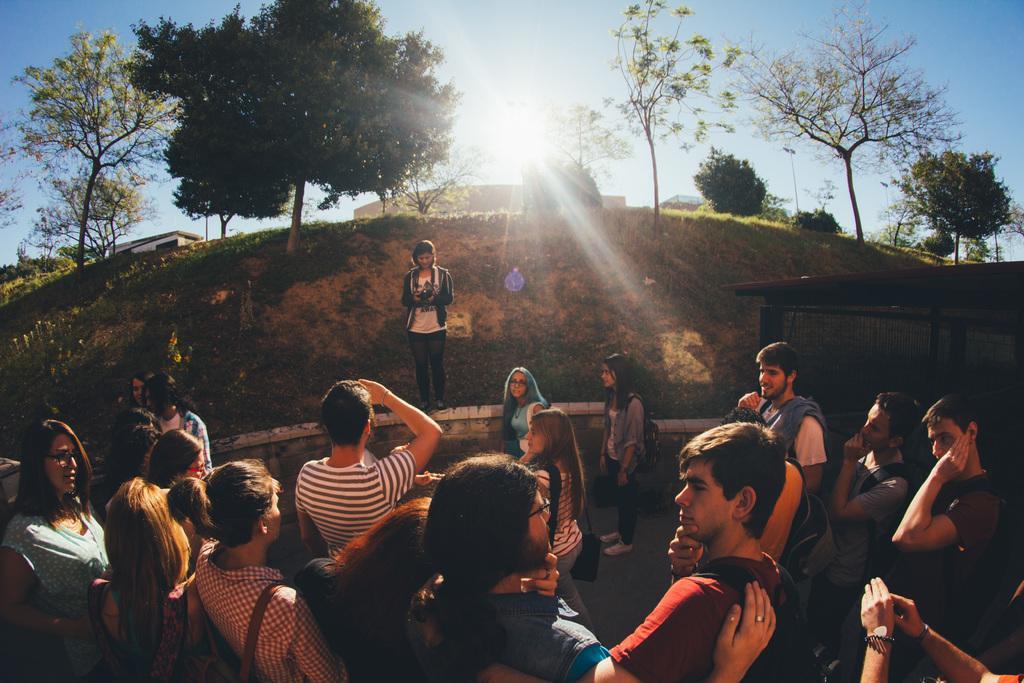Can you describe this image briefly? Group of people standing. Background we can see grass,trees and sky. 